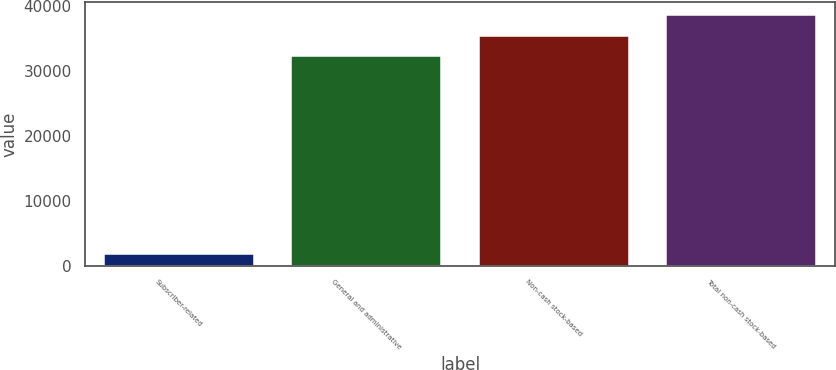<chart> <loc_0><loc_0><loc_500><loc_500><bar_chart><fcel>Subscriber-related<fcel>General and administrative<fcel>Non-cash stock-based<fcel>Total non-cash stock-based<nl><fcel>1859<fcel>32294<fcel>35523.4<fcel>38752.8<nl></chart> 